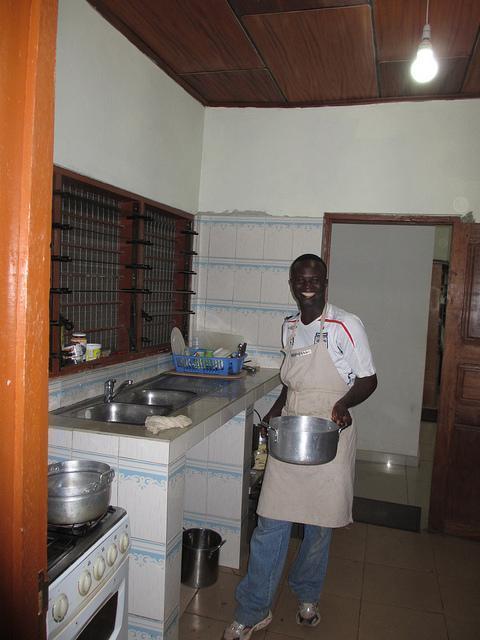How many bottles of wine?
Give a very brief answer. 0. How many workers are there?
Give a very brief answer. 1. How many televisions are on the left of the door?
Give a very brief answer. 0. 